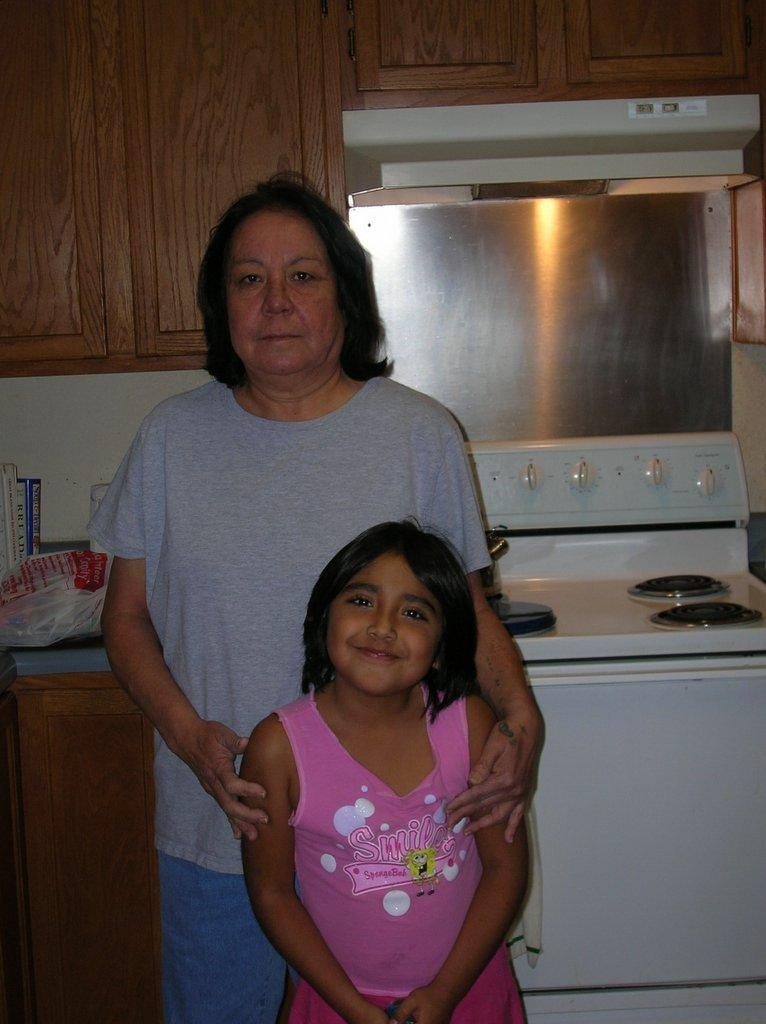<image>
Describe the image concisely. A woman and a little girl who has Sponge Bob on her tee shirt 